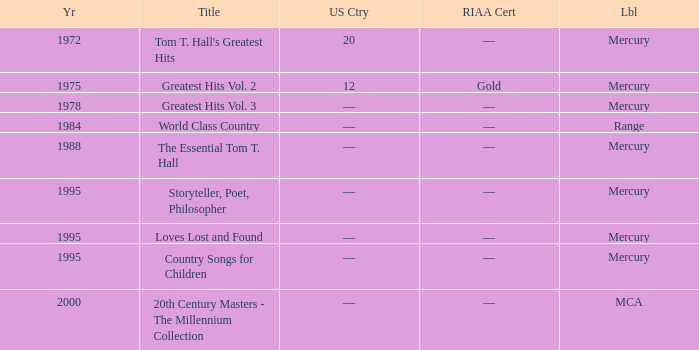What is the highest year for the title, "loves lost and found"? 1995.0. 